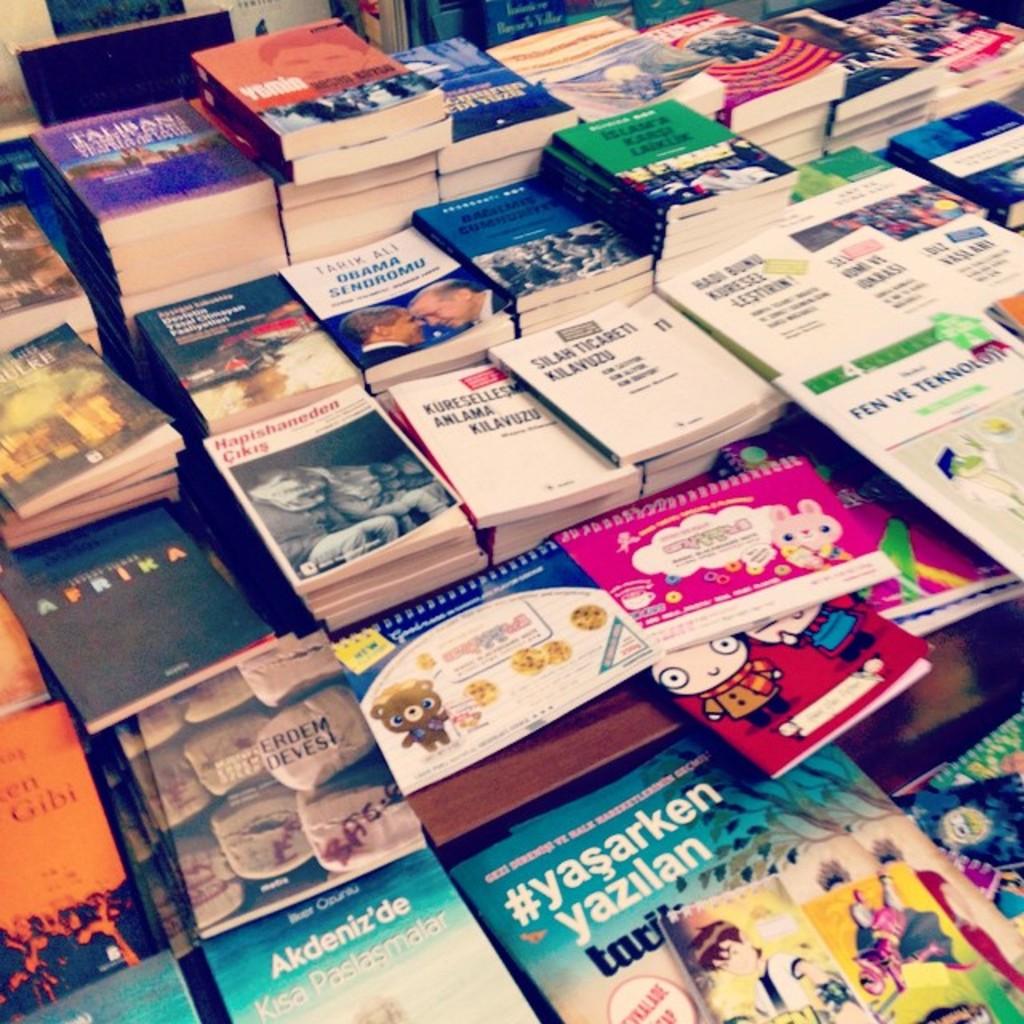What is the subject of the book in the back row with the purple cover?
Provide a short and direct response. Taliban. What is the hashtag on the bottom book?
Offer a terse response. #yasarken. 